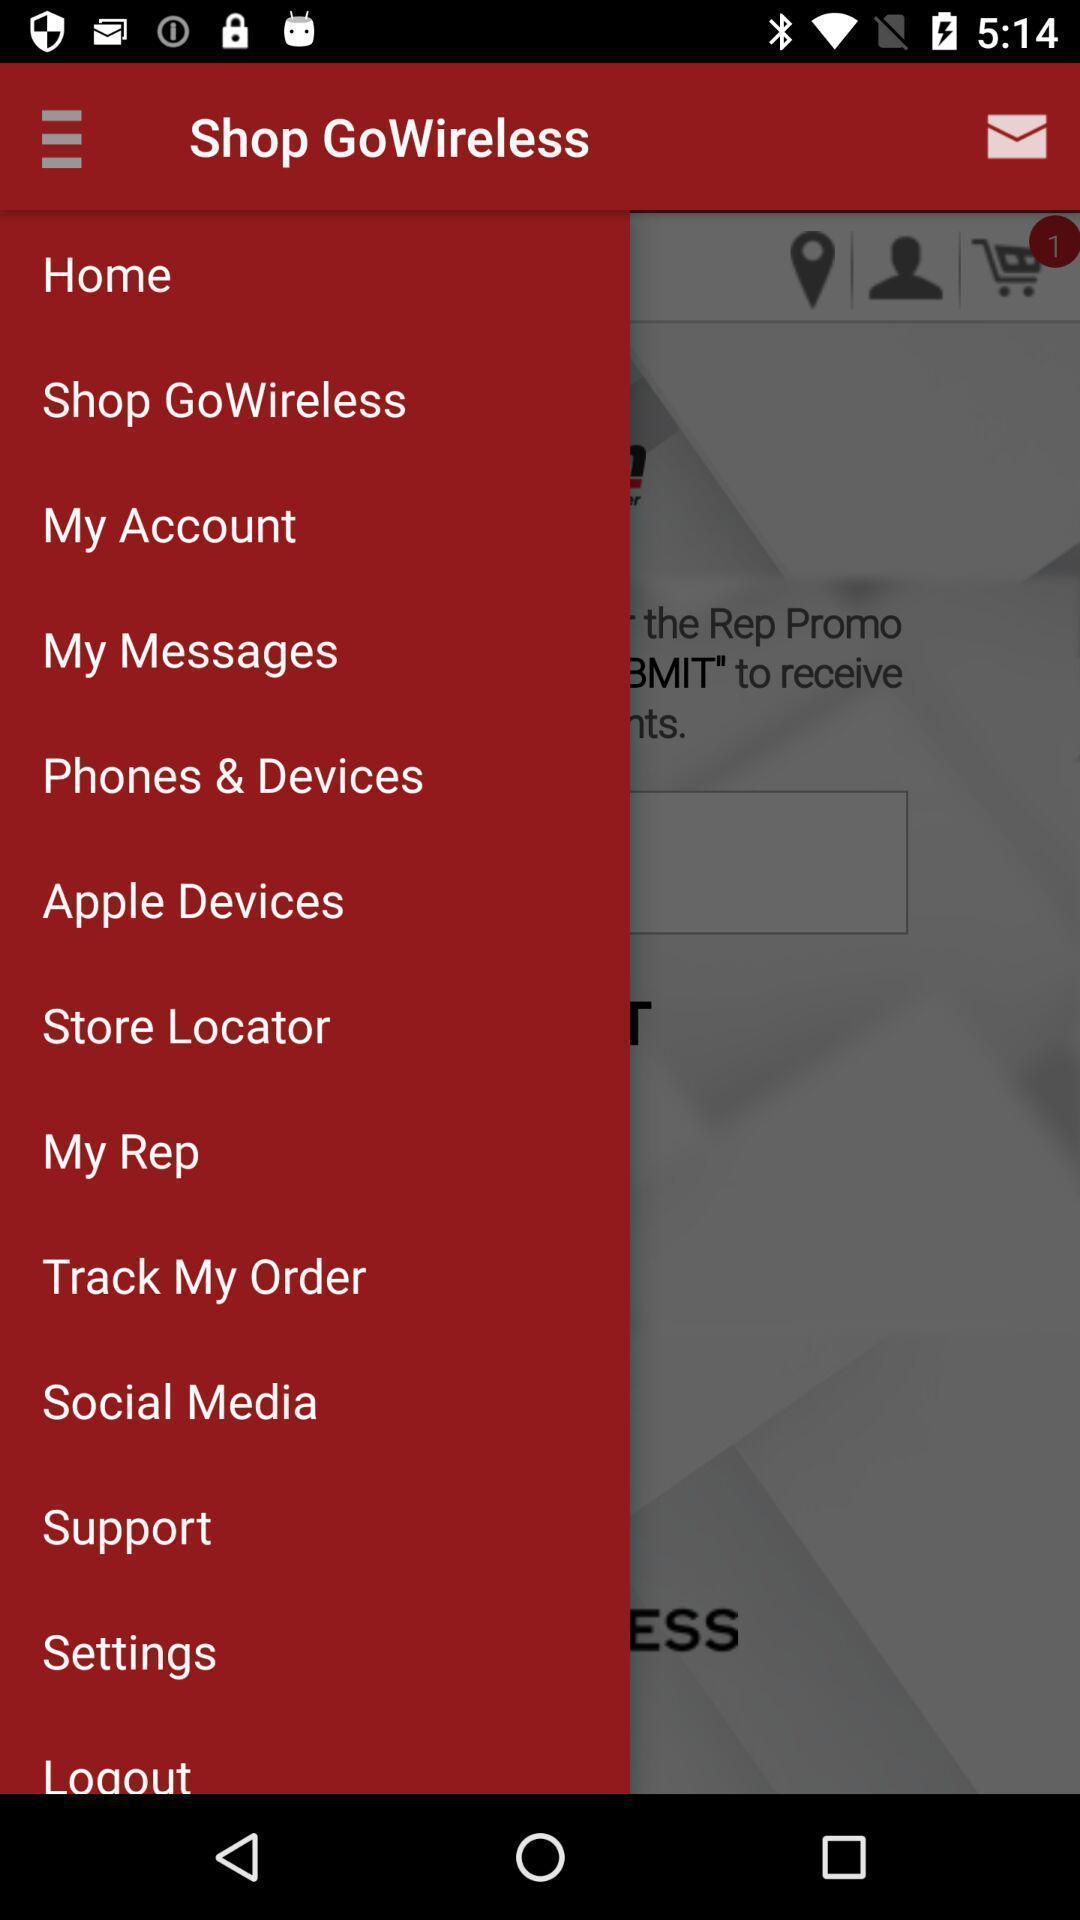Describe this image in words. Screen displaying options. 